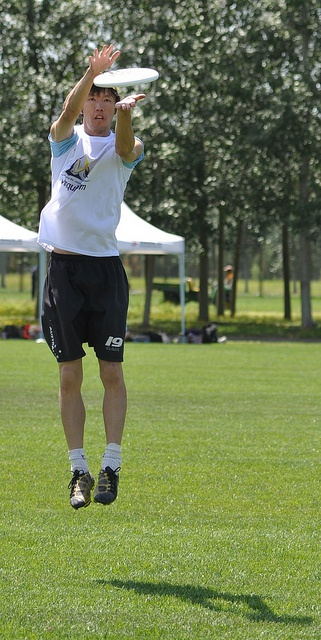Describe the objects in this image and their specific colors. I can see people in darkgray, black, and gray tones, frisbee in darkgray, white, gray, and lightblue tones, and people in darkgray, black, and gray tones in this image. 